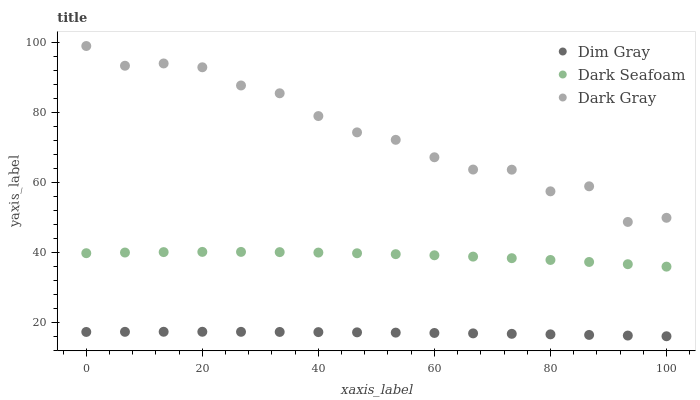Does Dim Gray have the minimum area under the curve?
Answer yes or no. Yes. Does Dark Gray have the maximum area under the curve?
Answer yes or no. Yes. Does Dark Seafoam have the minimum area under the curve?
Answer yes or no. No. Does Dark Seafoam have the maximum area under the curve?
Answer yes or no. No. Is Dim Gray the smoothest?
Answer yes or no. Yes. Is Dark Gray the roughest?
Answer yes or no. Yes. Is Dark Seafoam the smoothest?
Answer yes or no. No. Is Dark Seafoam the roughest?
Answer yes or no. No. Does Dim Gray have the lowest value?
Answer yes or no. Yes. Does Dark Seafoam have the lowest value?
Answer yes or no. No. Does Dark Gray have the highest value?
Answer yes or no. Yes. Does Dark Seafoam have the highest value?
Answer yes or no. No. Is Dim Gray less than Dark Seafoam?
Answer yes or no. Yes. Is Dark Seafoam greater than Dim Gray?
Answer yes or no. Yes. Does Dim Gray intersect Dark Seafoam?
Answer yes or no. No. 